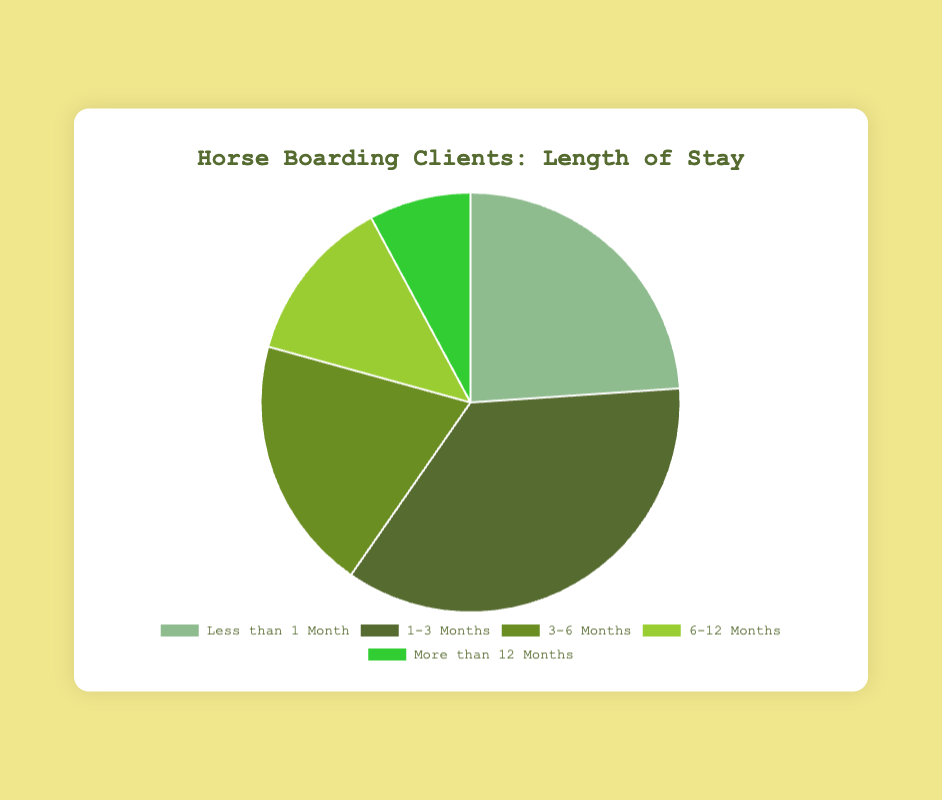What percentage of horse boarding clients stay for 1-3 months? Based on the chart, the data shows that 100 clients stay for 1-3 months out of a total of 280. The percentage is calculated as (100/280) * 100 = 35.7%.
Answer: 35.7% Which duration has the lowest number of clients? By visually inspecting the pie chart, "More than 12 Months" has the smallest slice, representing the lowest number of clients.
Answer: More than 12 Months How many clients stay for less than 6 months in total? Adding the clients staying for "Less than 1 Month", "1-3 Months", and "3-6 Months" gives 67 + 100 + 55 = 222 clients.
Answer: 222 Is there a higher percentage of clients who stay for less than 1 month or those who stay for more than 6 months combined? For less than 1 month: 67/280 = 23.9%. For more than 6 months combined: (36 + 22)/280 = 20.7%. So, less than 1 month has a higher percentage.
Answer: Less than 1 Month What is the difference in the number of clients between the "1-3 Months" and "6-12 Months" categories? The "1-3 Months" category has 100 clients while the "6-12 Months" category has 36 clients. The difference is 100 - 36 = 64 clients.
Answer: 64 clients Which duration category has the most clients, and how many? By visually inspecting the chart, "1-3 Months" has the largest slice representing 100 clients.
Answer: 1-3 Months, 100 clients What visual attribute can you use to identify the category with 10 clients staying for 3-6 months? The slice for "3-6 Months" has a specific shade of green color (as seen in the pie chart).
Answer: Shade of green What is the average number of clients across all durations? The total number of clients is 280. The average is calculated by dividing 280 by the 5 categories: 280 / 5 = 56 clients.
Answer: 56 clients Compare the number of clients staying "6-12 months" with "More than 12 Months" and state which is higher. "6-12 Months" has 36 clients and "More than 12 Months" has 22 clients. 36 is greater than 22, so "6-12 Months" has more clients.
Answer: 6-12 Months What percentage of clients stay for 6 months or more? Adding the number of clients for "6-12 Months" and "More than 12 Months" gives 36 + 22 = 58. The percentage is (58/280) * 100 ≈ 20.7%.
Answer: 20.7% 